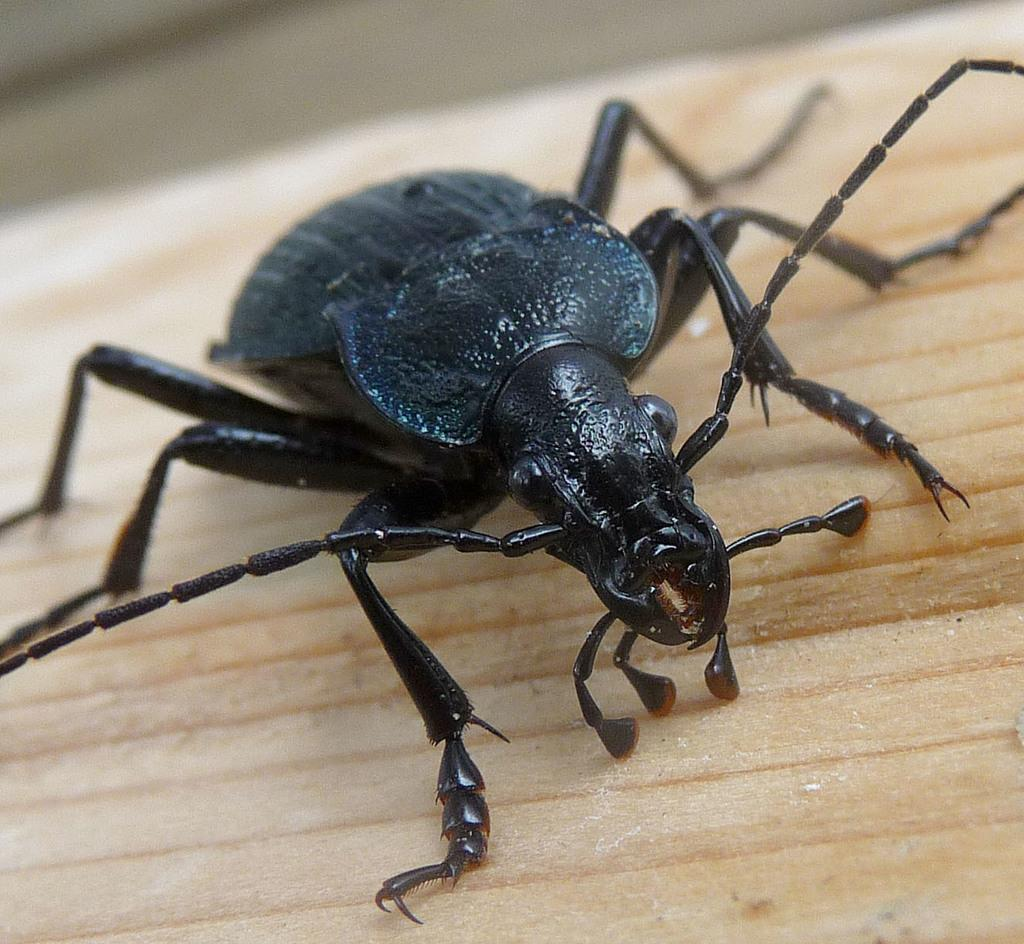What type of creature is in the image? There is a black insect in the image. What is the insect's location in the image? The insect is on a wooden floor. What type of bridge can be seen in the image? There is no bridge present in the image; it features a black insect on a wooden floor. Can you describe the cat's behavior in the image? There is no cat present in the image. 